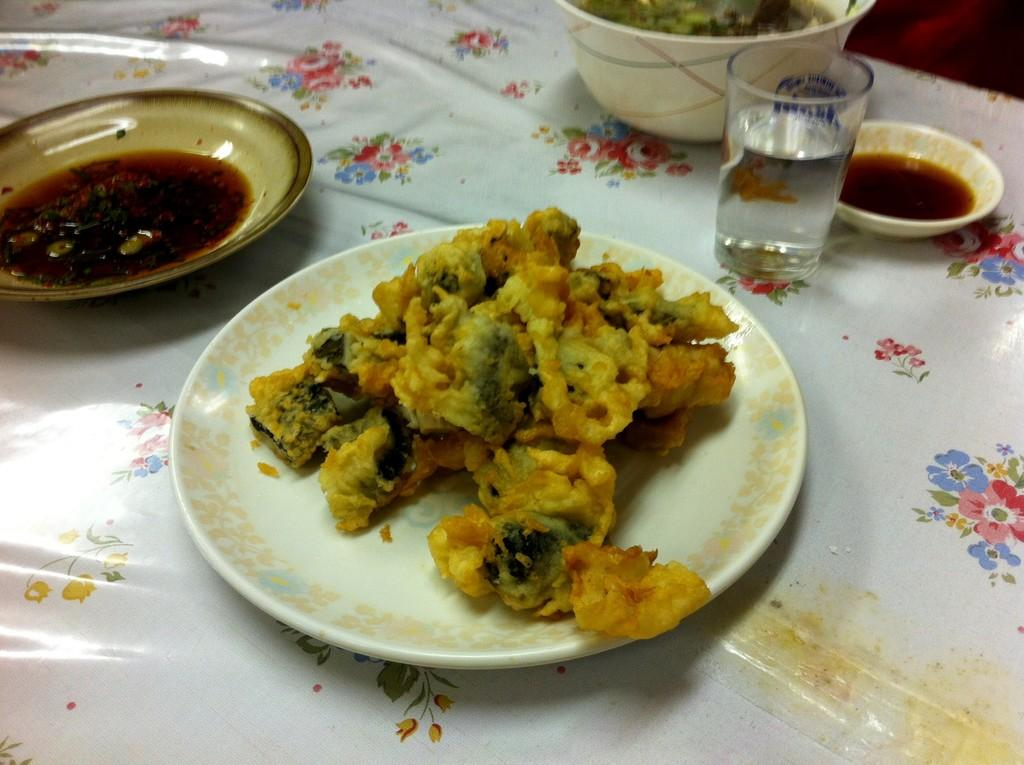What piece of furniture is present in the image? There is a table in the image. How many plates are on the table? There are two plates on the table. How many bowls are on the table? There are two bowls on the table. What is in the glass on the table? There is a glass of drink on the table. What is in the plates and bowls? There is food in the plates and bowls. Where is the basin located in the image? There is no basin present in the image. What type of flame can be seen in the image? There is no flame present in the image. 